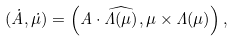<formula> <loc_0><loc_0><loc_500><loc_500>( \dot { A } , \dot { \mu } ) = \left ( A \cdot \widehat { \Lambda ( \mu ) } , \mu \times \Lambda ( \mu ) \right ) ,</formula> 